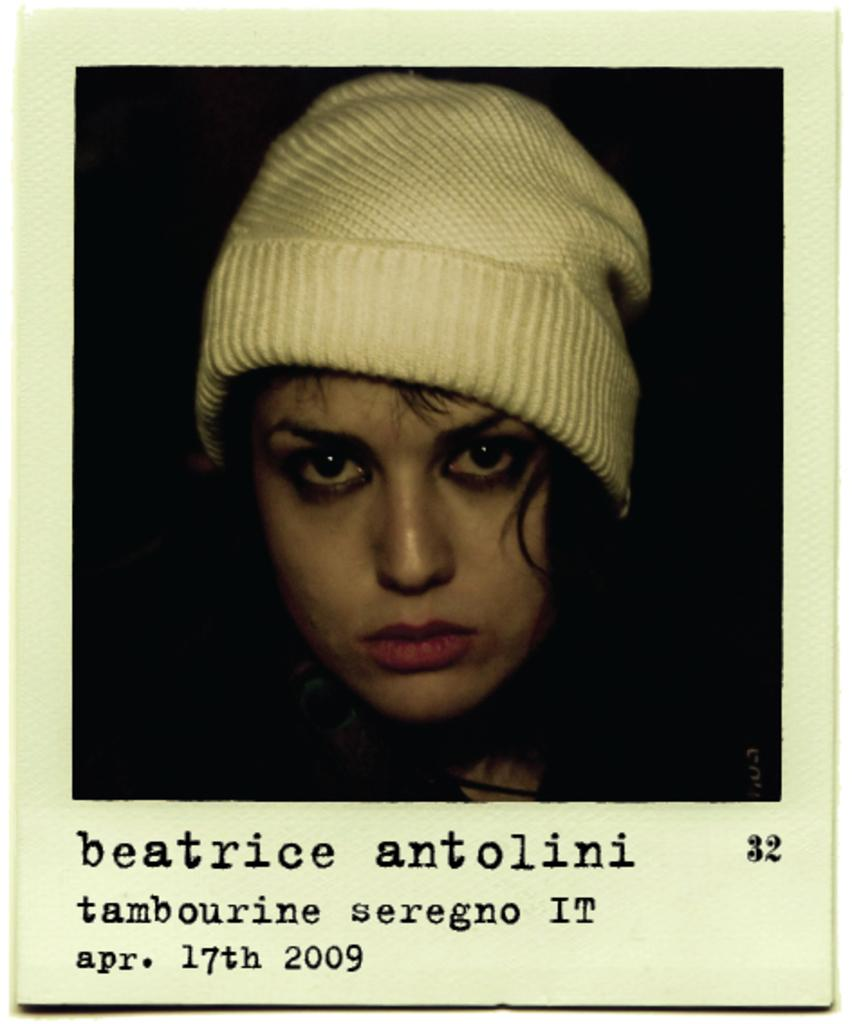What is the main subject of the image? There is a picture of a woman in the image. What is the woman wearing on her head? The woman is wearing a cream-colored cap. Is there any text present in the image? Yes, there is text written at the bottom of the image. What type of stone can be seen on the sofa in the image? There is no sofa or stone present in the image; it features a picture of a woman wearing a cap and text at the bottom. Can you describe the facial expression of the woman in the image? The facts provided do not mention the woman's facial expression, so it cannot be determined from the image. 